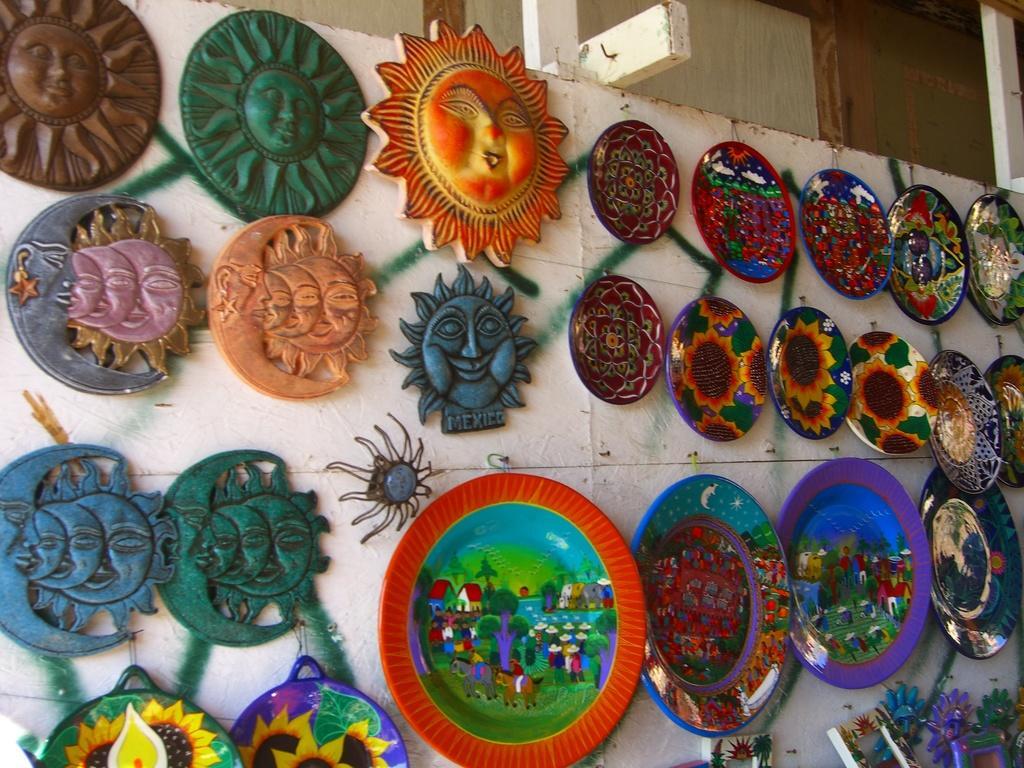Please provide a concise description of this image. In this image we can see some plates and other objects on the wall. 